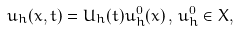<formula> <loc_0><loc_0><loc_500><loc_500>u _ { h } ( x , t ) = U _ { h } ( t ) u _ { h } ^ { 0 } ( x ) \, , \, u _ { h } ^ { 0 } \in X ,</formula> 